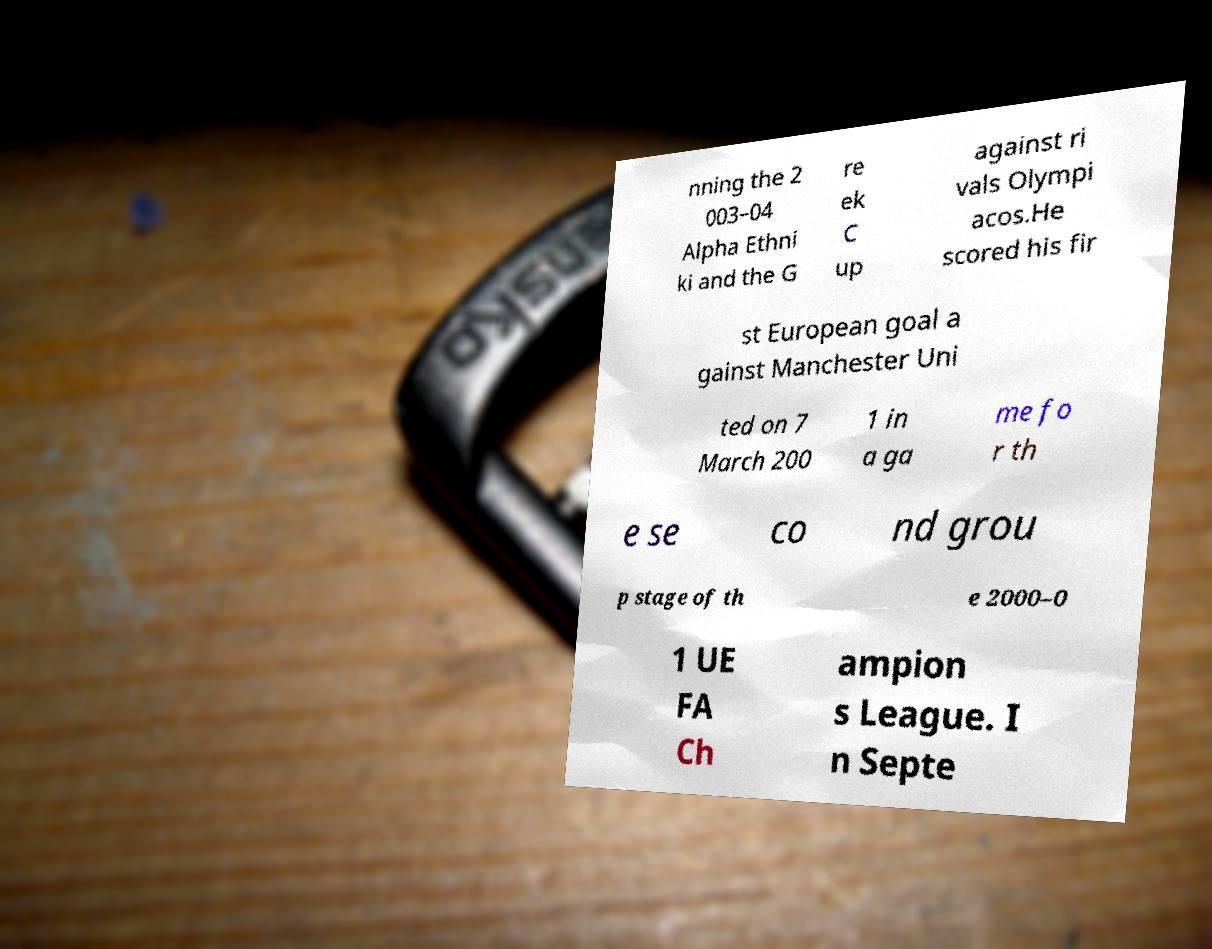Could you assist in decoding the text presented in this image and type it out clearly? nning the 2 003–04 Alpha Ethni ki and the G re ek C up against ri vals Olympi acos.He scored his fir st European goal a gainst Manchester Uni ted on 7 March 200 1 in a ga me fo r th e se co nd grou p stage of th e 2000–0 1 UE FA Ch ampion s League. I n Septe 